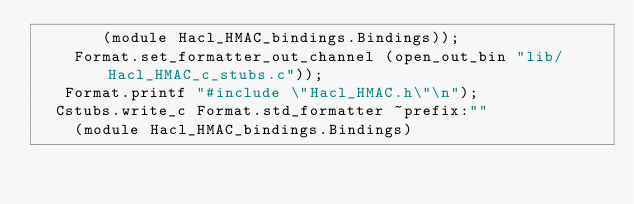Convert code to text. <code><loc_0><loc_0><loc_500><loc_500><_OCaml_>       (module Hacl_HMAC_bindings.Bindings));
    Format.set_formatter_out_channel (open_out_bin "lib/Hacl_HMAC_c_stubs.c"));
   Format.printf "#include \"Hacl_HMAC.h\"\n");
  Cstubs.write_c Format.std_formatter ~prefix:""
    (module Hacl_HMAC_bindings.Bindings)</code> 